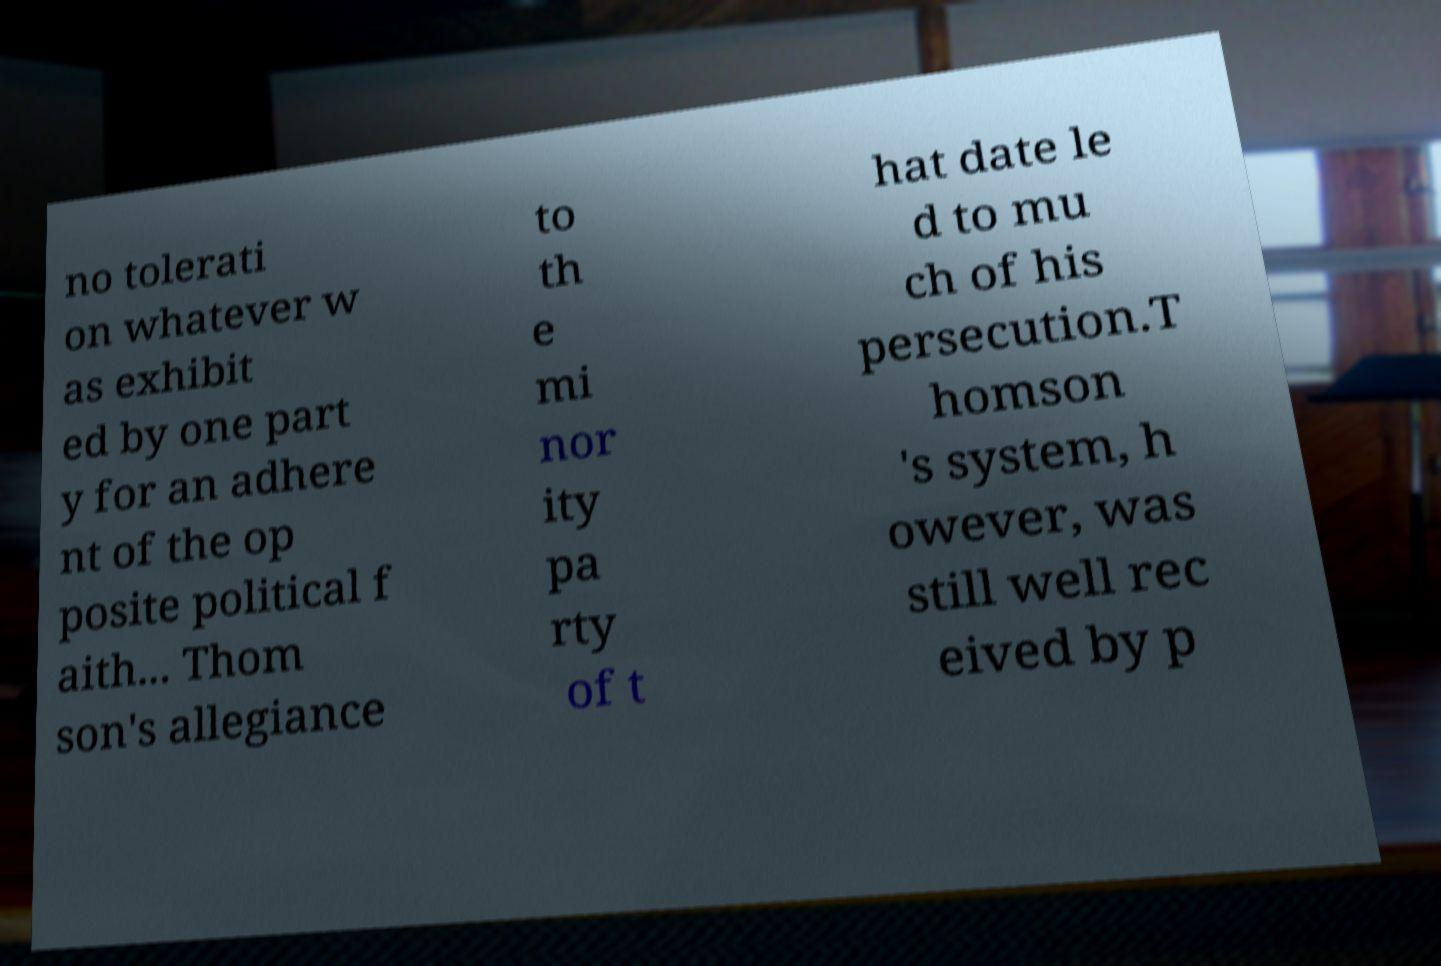Can you read and provide the text displayed in the image?This photo seems to have some interesting text. Can you extract and type it out for me? no tolerati on whatever w as exhibit ed by one part y for an adhere nt of the op posite political f aith... Thom son's allegiance to th e mi nor ity pa rty of t hat date le d to mu ch of his persecution.T homson 's system, h owever, was still well rec eived by p 